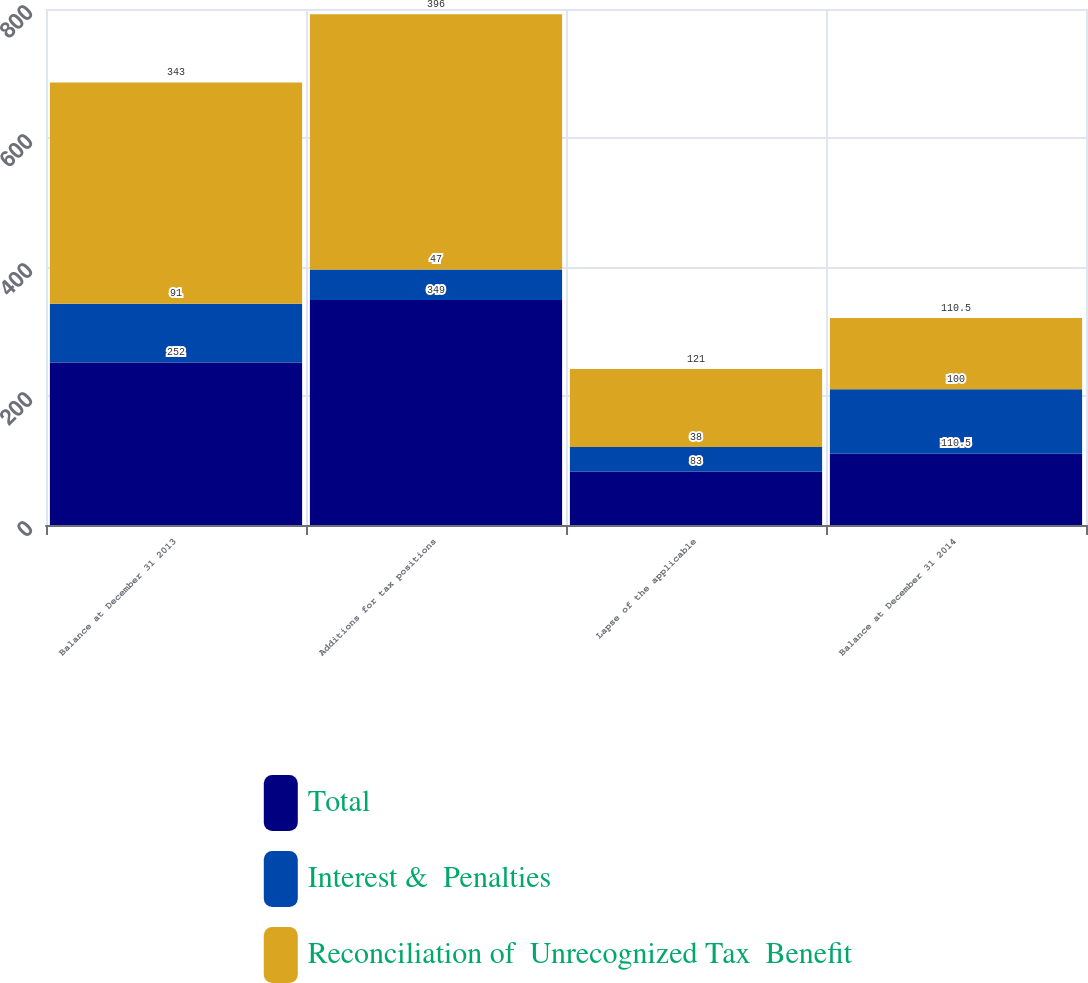<chart> <loc_0><loc_0><loc_500><loc_500><stacked_bar_chart><ecel><fcel>Balance at December 31 2013<fcel>Additions for tax positions<fcel>Lapse of the applicable<fcel>Balance at December 31 2014<nl><fcel>Total<fcel>252<fcel>349<fcel>83<fcel>110.5<nl><fcel>Interest &  Penalties<fcel>91<fcel>47<fcel>38<fcel>100<nl><fcel>Reconciliation of  Unrecognized Tax  Benefit<fcel>343<fcel>396<fcel>121<fcel>110.5<nl></chart> 